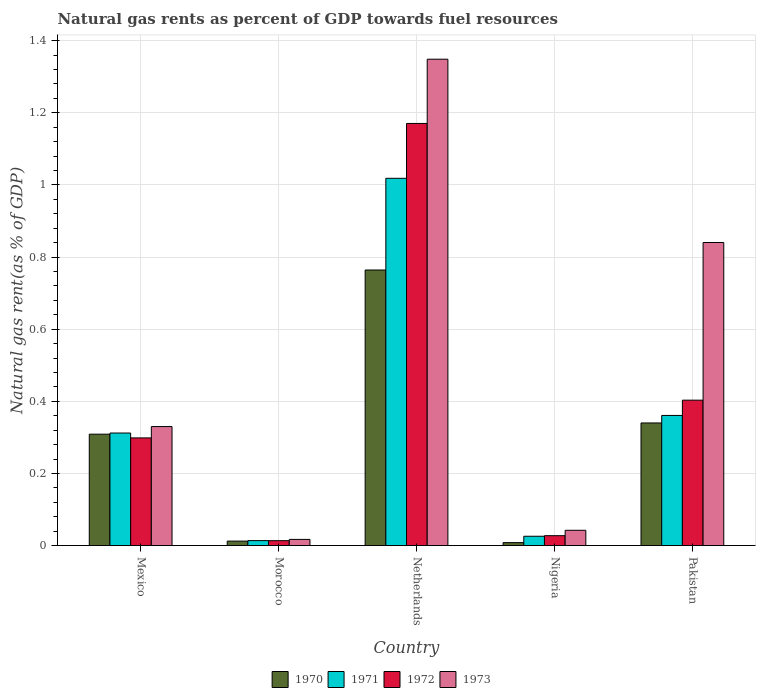How many different coloured bars are there?
Your answer should be compact. 4. How many groups of bars are there?
Give a very brief answer. 5. Are the number of bars on each tick of the X-axis equal?
Provide a succinct answer. Yes. In how many cases, is the number of bars for a given country not equal to the number of legend labels?
Ensure brevity in your answer.  0. What is the natural gas rent in 1973 in Netherlands?
Make the answer very short. 1.35. Across all countries, what is the maximum natural gas rent in 1972?
Provide a succinct answer. 1.17. Across all countries, what is the minimum natural gas rent in 1970?
Your response must be concise. 0.01. In which country was the natural gas rent in 1971 minimum?
Offer a very short reply. Morocco. What is the total natural gas rent in 1972 in the graph?
Keep it short and to the point. 1.91. What is the difference between the natural gas rent in 1970 in Mexico and that in Pakistan?
Offer a very short reply. -0.03. What is the difference between the natural gas rent in 1971 in Morocco and the natural gas rent in 1970 in Nigeria?
Make the answer very short. 0.01. What is the average natural gas rent in 1970 per country?
Make the answer very short. 0.29. What is the difference between the natural gas rent of/in 1970 and natural gas rent of/in 1972 in Netherlands?
Provide a short and direct response. -0.41. In how many countries, is the natural gas rent in 1971 greater than 0.4 %?
Keep it short and to the point. 1. What is the ratio of the natural gas rent in 1972 in Netherlands to that in Pakistan?
Your answer should be compact. 2.9. Is the difference between the natural gas rent in 1970 in Nigeria and Pakistan greater than the difference between the natural gas rent in 1972 in Nigeria and Pakistan?
Offer a very short reply. Yes. What is the difference between the highest and the second highest natural gas rent in 1970?
Ensure brevity in your answer.  0.42. What is the difference between the highest and the lowest natural gas rent in 1971?
Ensure brevity in your answer.  1. In how many countries, is the natural gas rent in 1970 greater than the average natural gas rent in 1970 taken over all countries?
Offer a terse response. 3. What does the 1st bar from the left in Morocco represents?
Make the answer very short. 1970. Is it the case that in every country, the sum of the natural gas rent in 1970 and natural gas rent in 1973 is greater than the natural gas rent in 1972?
Your answer should be compact. Yes. How many bars are there?
Your answer should be very brief. 20. How many countries are there in the graph?
Offer a very short reply. 5. What is the difference between two consecutive major ticks on the Y-axis?
Provide a succinct answer. 0.2. Does the graph contain grids?
Offer a terse response. Yes. Where does the legend appear in the graph?
Your answer should be compact. Bottom center. How many legend labels are there?
Provide a short and direct response. 4. What is the title of the graph?
Ensure brevity in your answer.  Natural gas rents as percent of GDP towards fuel resources. What is the label or title of the X-axis?
Offer a very short reply. Country. What is the label or title of the Y-axis?
Offer a very short reply. Natural gas rent(as % of GDP). What is the Natural gas rent(as % of GDP) of 1970 in Mexico?
Your answer should be very brief. 0.31. What is the Natural gas rent(as % of GDP) of 1971 in Mexico?
Provide a succinct answer. 0.31. What is the Natural gas rent(as % of GDP) in 1972 in Mexico?
Offer a terse response. 0.3. What is the Natural gas rent(as % of GDP) of 1973 in Mexico?
Your answer should be very brief. 0.33. What is the Natural gas rent(as % of GDP) of 1970 in Morocco?
Your response must be concise. 0.01. What is the Natural gas rent(as % of GDP) in 1971 in Morocco?
Make the answer very short. 0.01. What is the Natural gas rent(as % of GDP) of 1972 in Morocco?
Provide a short and direct response. 0.01. What is the Natural gas rent(as % of GDP) of 1973 in Morocco?
Make the answer very short. 0.02. What is the Natural gas rent(as % of GDP) of 1970 in Netherlands?
Offer a very short reply. 0.76. What is the Natural gas rent(as % of GDP) in 1971 in Netherlands?
Your response must be concise. 1.02. What is the Natural gas rent(as % of GDP) in 1972 in Netherlands?
Your response must be concise. 1.17. What is the Natural gas rent(as % of GDP) of 1973 in Netherlands?
Provide a succinct answer. 1.35. What is the Natural gas rent(as % of GDP) of 1970 in Nigeria?
Keep it short and to the point. 0.01. What is the Natural gas rent(as % of GDP) of 1971 in Nigeria?
Offer a very short reply. 0.03. What is the Natural gas rent(as % of GDP) of 1972 in Nigeria?
Keep it short and to the point. 0.03. What is the Natural gas rent(as % of GDP) of 1973 in Nigeria?
Offer a terse response. 0.04. What is the Natural gas rent(as % of GDP) in 1970 in Pakistan?
Keep it short and to the point. 0.34. What is the Natural gas rent(as % of GDP) of 1971 in Pakistan?
Provide a short and direct response. 0.36. What is the Natural gas rent(as % of GDP) of 1972 in Pakistan?
Ensure brevity in your answer.  0.4. What is the Natural gas rent(as % of GDP) of 1973 in Pakistan?
Offer a very short reply. 0.84. Across all countries, what is the maximum Natural gas rent(as % of GDP) of 1970?
Keep it short and to the point. 0.76. Across all countries, what is the maximum Natural gas rent(as % of GDP) in 1971?
Your answer should be very brief. 1.02. Across all countries, what is the maximum Natural gas rent(as % of GDP) in 1972?
Your answer should be very brief. 1.17. Across all countries, what is the maximum Natural gas rent(as % of GDP) in 1973?
Ensure brevity in your answer.  1.35. Across all countries, what is the minimum Natural gas rent(as % of GDP) of 1970?
Offer a terse response. 0.01. Across all countries, what is the minimum Natural gas rent(as % of GDP) of 1971?
Your response must be concise. 0.01. Across all countries, what is the minimum Natural gas rent(as % of GDP) in 1972?
Your answer should be compact. 0.01. Across all countries, what is the minimum Natural gas rent(as % of GDP) in 1973?
Offer a very short reply. 0.02. What is the total Natural gas rent(as % of GDP) in 1970 in the graph?
Your response must be concise. 1.43. What is the total Natural gas rent(as % of GDP) of 1971 in the graph?
Your response must be concise. 1.73. What is the total Natural gas rent(as % of GDP) of 1972 in the graph?
Your response must be concise. 1.91. What is the total Natural gas rent(as % of GDP) of 1973 in the graph?
Provide a short and direct response. 2.58. What is the difference between the Natural gas rent(as % of GDP) of 1970 in Mexico and that in Morocco?
Your answer should be very brief. 0.3. What is the difference between the Natural gas rent(as % of GDP) of 1971 in Mexico and that in Morocco?
Offer a terse response. 0.3. What is the difference between the Natural gas rent(as % of GDP) in 1972 in Mexico and that in Morocco?
Offer a terse response. 0.28. What is the difference between the Natural gas rent(as % of GDP) of 1973 in Mexico and that in Morocco?
Your answer should be very brief. 0.31. What is the difference between the Natural gas rent(as % of GDP) in 1970 in Mexico and that in Netherlands?
Your answer should be compact. -0.46. What is the difference between the Natural gas rent(as % of GDP) of 1971 in Mexico and that in Netherlands?
Keep it short and to the point. -0.71. What is the difference between the Natural gas rent(as % of GDP) in 1972 in Mexico and that in Netherlands?
Make the answer very short. -0.87. What is the difference between the Natural gas rent(as % of GDP) of 1973 in Mexico and that in Netherlands?
Make the answer very short. -1.02. What is the difference between the Natural gas rent(as % of GDP) of 1970 in Mexico and that in Nigeria?
Your answer should be compact. 0.3. What is the difference between the Natural gas rent(as % of GDP) of 1971 in Mexico and that in Nigeria?
Your answer should be very brief. 0.29. What is the difference between the Natural gas rent(as % of GDP) in 1972 in Mexico and that in Nigeria?
Your answer should be very brief. 0.27. What is the difference between the Natural gas rent(as % of GDP) of 1973 in Mexico and that in Nigeria?
Provide a succinct answer. 0.29. What is the difference between the Natural gas rent(as % of GDP) of 1970 in Mexico and that in Pakistan?
Ensure brevity in your answer.  -0.03. What is the difference between the Natural gas rent(as % of GDP) of 1971 in Mexico and that in Pakistan?
Give a very brief answer. -0.05. What is the difference between the Natural gas rent(as % of GDP) of 1972 in Mexico and that in Pakistan?
Your answer should be compact. -0.1. What is the difference between the Natural gas rent(as % of GDP) of 1973 in Mexico and that in Pakistan?
Your response must be concise. -0.51. What is the difference between the Natural gas rent(as % of GDP) of 1970 in Morocco and that in Netherlands?
Keep it short and to the point. -0.75. What is the difference between the Natural gas rent(as % of GDP) of 1971 in Morocco and that in Netherlands?
Make the answer very short. -1. What is the difference between the Natural gas rent(as % of GDP) of 1972 in Morocco and that in Netherlands?
Offer a terse response. -1.16. What is the difference between the Natural gas rent(as % of GDP) of 1973 in Morocco and that in Netherlands?
Offer a very short reply. -1.33. What is the difference between the Natural gas rent(as % of GDP) in 1970 in Morocco and that in Nigeria?
Give a very brief answer. 0. What is the difference between the Natural gas rent(as % of GDP) in 1971 in Morocco and that in Nigeria?
Provide a succinct answer. -0.01. What is the difference between the Natural gas rent(as % of GDP) in 1972 in Morocco and that in Nigeria?
Provide a succinct answer. -0.01. What is the difference between the Natural gas rent(as % of GDP) in 1973 in Morocco and that in Nigeria?
Keep it short and to the point. -0.03. What is the difference between the Natural gas rent(as % of GDP) in 1970 in Morocco and that in Pakistan?
Offer a terse response. -0.33. What is the difference between the Natural gas rent(as % of GDP) in 1971 in Morocco and that in Pakistan?
Keep it short and to the point. -0.35. What is the difference between the Natural gas rent(as % of GDP) in 1972 in Morocco and that in Pakistan?
Provide a short and direct response. -0.39. What is the difference between the Natural gas rent(as % of GDP) in 1973 in Morocco and that in Pakistan?
Give a very brief answer. -0.82. What is the difference between the Natural gas rent(as % of GDP) in 1970 in Netherlands and that in Nigeria?
Your response must be concise. 0.76. What is the difference between the Natural gas rent(as % of GDP) of 1971 in Netherlands and that in Nigeria?
Your answer should be compact. 0.99. What is the difference between the Natural gas rent(as % of GDP) in 1972 in Netherlands and that in Nigeria?
Your answer should be compact. 1.14. What is the difference between the Natural gas rent(as % of GDP) of 1973 in Netherlands and that in Nigeria?
Make the answer very short. 1.31. What is the difference between the Natural gas rent(as % of GDP) of 1970 in Netherlands and that in Pakistan?
Make the answer very short. 0.42. What is the difference between the Natural gas rent(as % of GDP) in 1971 in Netherlands and that in Pakistan?
Your answer should be compact. 0.66. What is the difference between the Natural gas rent(as % of GDP) of 1972 in Netherlands and that in Pakistan?
Provide a short and direct response. 0.77. What is the difference between the Natural gas rent(as % of GDP) of 1973 in Netherlands and that in Pakistan?
Keep it short and to the point. 0.51. What is the difference between the Natural gas rent(as % of GDP) of 1970 in Nigeria and that in Pakistan?
Give a very brief answer. -0.33. What is the difference between the Natural gas rent(as % of GDP) in 1971 in Nigeria and that in Pakistan?
Offer a terse response. -0.34. What is the difference between the Natural gas rent(as % of GDP) in 1972 in Nigeria and that in Pakistan?
Provide a short and direct response. -0.38. What is the difference between the Natural gas rent(as % of GDP) of 1973 in Nigeria and that in Pakistan?
Provide a succinct answer. -0.8. What is the difference between the Natural gas rent(as % of GDP) of 1970 in Mexico and the Natural gas rent(as % of GDP) of 1971 in Morocco?
Make the answer very short. 0.3. What is the difference between the Natural gas rent(as % of GDP) of 1970 in Mexico and the Natural gas rent(as % of GDP) of 1972 in Morocco?
Your answer should be compact. 0.3. What is the difference between the Natural gas rent(as % of GDP) of 1970 in Mexico and the Natural gas rent(as % of GDP) of 1973 in Morocco?
Your response must be concise. 0.29. What is the difference between the Natural gas rent(as % of GDP) in 1971 in Mexico and the Natural gas rent(as % of GDP) in 1972 in Morocco?
Your answer should be compact. 0.3. What is the difference between the Natural gas rent(as % of GDP) in 1971 in Mexico and the Natural gas rent(as % of GDP) in 1973 in Morocco?
Your answer should be compact. 0.29. What is the difference between the Natural gas rent(as % of GDP) in 1972 in Mexico and the Natural gas rent(as % of GDP) in 1973 in Morocco?
Make the answer very short. 0.28. What is the difference between the Natural gas rent(as % of GDP) in 1970 in Mexico and the Natural gas rent(as % of GDP) in 1971 in Netherlands?
Your answer should be compact. -0.71. What is the difference between the Natural gas rent(as % of GDP) of 1970 in Mexico and the Natural gas rent(as % of GDP) of 1972 in Netherlands?
Offer a terse response. -0.86. What is the difference between the Natural gas rent(as % of GDP) of 1970 in Mexico and the Natural gas rent(as % of GDP) of 1973 in Netherlands?
Your response must be concise. -1.04. What is the difference between the Natural gas rent(as % of GDP) of 1971 in Mexico and the Natural gas rent(as % of GDP) of 1972 in Netherlands?
Your answer should be compact. -0.86. What is the difference between the Natural gas rent(as % of GDP) of 1971 in Mexico and the Natural gas rent(as % of GDP) of 1973 in Netherlands?
Make the answer very short. -1.04. What is the difference between the Natural gas rent(as % of GDP) in 1972 in Mexico and the Natural gas rent(as % of GDP) in 1973 in Netherlands?
Keep it short and to the point. -1.05. What is the difference between the Natural gas rent(as % of GDP) in 1970 in Mexico and the Natural gas rent(as % of GDP) in 1971 in Nigeria?
Offer a terse response. 0.28. What is the difference between the Natural gas rent(as % of GDP) in 1970 in Mexico and the Natural gas rent(as % of GDP) in 1972 in Nigeria?
Provide a succinct answer. 0.28. What is the difference between the Natural gas rent(as % of GDP) of 1970 in Mexico and the Natural gas rent(as % of GDP) of 1973 in Nigeria?
Keep it short and to the point. 0.27. What is the difference between the Natural gas rent(as % of GDP) in 1971 in Mexico and the Natural gas rent(as % of GDP) in 1972 in Nigeria?
Your answer should be compact. 0.28. What is the difference between the Natural gas rent(as % of GDP) of 1971 in Mexico and the Natural gas rent(as % of GDP) of 1973 in Nigeria?
Make the answer very short. 0.27. What is the difference between the Natural gas rent(as % of GDP) of 1972 in Mexico and the Natural gas rent(as % of GDP) of 1973 in Nigeria?
Your answer should be compact. 0.26. What is the difference between the Natural gas rent(as % of GDP) in 1970 in Mexico and the Natural gas rent(as % of GDP) in 1971 in Pakistan?
Your answer should be very brief. -0.05. What is the difference between the Natural gas rent(as % of GDP) of 1970 in Mexico and the Natural gas rent(as % of GDP) of 1972 in Pakistan?
Your answer should be very brief. -0.09. What is the difference between the Natural gas rent(as % of GDP) in 1970 in Mexico and the Natural gas rent(as % of GDP) in 1973 in Pakistan?
Ensure brevity in your answer.  -0.53. What is the difference between the Natural gas rent(as % of GDP) of 1971 in Mexico and the Natural gas rent(as % of GDP) of 1972 in Pakistan?
Keep it short and to the point. -0.09. What is the difference between the Natural gas rent(as % of GDP) in 1971 in Mexico and the Natural gas rent(as % of GDP) in 1973 in Pakistan?
Make the answer very short. -0.53. What is the difference between the Natural gas rent(as % of GDP) of 1972 in Mexico and the Natural gas rent(as % of GDP) of 1973 in Pakistan?
Your response must be concise. -0.54. What is the difference between the Natural gas rent(as % of GDP) of 1970 in Morocco and the Natural gas rent(as % of GDP) of 1971 in Netherlands?
Your answer should be compact. -1.01. What is the difference between the Natural gas rent(as % of GDP) of 1970 in Morocco and the Natural gas rent(as % of GDP) of 1972 in Netherlands?
Provide a succinct answer. -1.16. What is the difference between the Natural gas rent(as % of GDP) in 1970 in Morocco and the Natural gas rent(as % of GDP) in 1973 in Netherlands?
Give a very brief answer. -1.34. What is the difference between the Natural gas rent(as % of GDP) of 1971 in Morocco and the Natural gas rent(as % of GDP) of 1972 in Netherlands?
Provide a succinct answer. -1.16. What is the difference between the Natural gas rent(as % of GDP) in 1971 in Morocco and the Natural gas rent(as % of GDP) in 1973 in Netherlands?
Offer a terse response. -1.33. What is the difference between the Natural gas rent(as % of GDP) in 1972 in Morocco and the Natural gas rent(as % of GDP) in 1973 in Netherlands?
Ensure brevity in your answer.  -1.34. What is the difference between the Natural gas rent(as % of GDP) in 1970 in Morocco and the Natural gas rent(as % of GDP) in 1971 in Nigeria?
Make the answer very short. -0.01. What is the difference between the Natural gas rent(as % of GDP) of 1970 in Morocco and the Natural gas rent(as % of GDP) of 1972 in Nigeria?
Your answer should be compact. -0.02. What is the difference between the Natural gas rent(as % of GDP) of 1970 in Morocco and the Natural gas rent(as % of GDP) of 1973 in Nigeria?
Give a very brief answer. -0.03. What is the difference between the Natural gas rent(as % of GDP) in 1971 in Morocco and the Natural gas rent(as % of GDP) in 1972 in Nigeria?
Give a very brief answer. -0.01. What is the difference between the Natural gas rent(as % of GDP) in 1971 in Morocco and the Natural gas rent(as % of GDP) in 1973 in Nigeria?
Your answer should be very brief. -0.03. What is the difference between the Natural gas rent(as % of GDP) in 1972 in Morocco and the Natural gas rent(as % of GDP) in 1973 in Nigeria?
Your response must be concise. -0.03. What is the difference between the Natural gas rent(as % of GDP) of 1970 in Morocco and the Natural gas rent(as % of GDP) of 1971 in Pakistan?
Provide a short and direct response. -0.35. What is the difference between the Natural gas rent(as % of GDP) of 1970 in Morocco and the Natural gas rent(as % of GDP) of 1972 in Pakistan?
Make the answer very short. -0.39. What is the difference between the Natural gas rent(as % of GDP) in 1970 in Morocco and the Natural gas rent(as % of GDP) in 1973 in Pakistan?
Provide a succinct answer. -0.83. What is the difference between the Natural gas rent(as % of GDP) in 1971 in Morocco and the Natural gas rent(as % of GDP) in 1972 in Pakistan?
Give a very brief answer. -0.39. What is the difference between the Natural gas rent(as % of GDP) of 1971 in Morocco and the Natural gas rent(as % of GDP) of 1973 in Pakistan?
Make the answer very short. -0.83. What is the difference between the Natural gas rent(as % of GDP) in 1972 in Morocco and the Natural gas rent(as % of GDP) in 1973 in Pakistan?
Your response must be concise. -0.83. What is the difference between the Natural gas rent(as % of GDP) of 1970 in Netherlands and the Natural gas rent(as % of GDP) of 1971 in Nigeria?
Ensure brevity in your answer.  0.74. What is the difference between the Natural gas rent(as % of GDP) in 1970 in Netherlands and the Natural gas rent(as % of GDP) in 1972 in Nigeria?
Your response must be concise. 0.74. What is the difference between the Natural gas rent(as % of GDP) of 1970 in Netherlands and the Natural gas rent(as % of GDP) of 1973 in Nigeria?
Your response must be concise. 0.72. What is the difference between the Natural gas rent(as % of GDP) in 1972 in Netherlands and the Natural gas rent(as % of GDP) in 1973 in Nigeria?
Make the answer very short. 1.13. What is the difference between the Natural gas rent(as % of GDP) of 1970 in Netherlands and the Natural gas rent(as % of GDP) of 1971 in Pakistan?
Offer a very short reply. 0.4. What is the difference between the Natural gas rent(as % of GDP) in 1970 in Netherlands and the Natural gas rent(as % of GDP) in 1972 in Pakistan?
Keep it short and to the point. 0.36. What is the difference between the Natural gas rent(as % of GDP) in 1970 in Netherlands and the Natural gas rent(as % of GDP) in 1973 in Pakistan?
Provide a succinct answer. -0.08. What is the difference between the Natural gas rent(as % of GDP) of 1971 in Netherlands and the Natural gas rent(as % of GDP) of 1972 in Pakistan?
Offer a terse response. 0.62. What is the difference between the Natural gas rent(as % of GDP) of 1971 in Netherlands and the Natural gas rent(as % of GDP) of 1973 in Pakistan?
Keep it short and to the point. 0.18. What is the difference between the Natural gas rent(as % of GDP) of 1972 in Netherlands and the Natural gas rent(as % of GDP) of 1973 in Pakistan?
Offer a terse response. 0.33. What is the difference between the Natural gas rent(as % of GDP) in 1970 in Nigeria and the Natural gas rent(as % of GDP) in 1971 in Pakistan?
Your answer should be very brief. -0.35. What is the difference between the Natural gas rent(as % of GDP) in 1970 in Nigeria and the Natural gas rent(as % of GDP) in 1972 in Pakistan?
Offer a terse response. -0.4. What is the difference between the Natural gas rent(as % of GDP) in 1970 in Nigeria and the Natural gas rent(as % of GDP) in 1973 in Pakistan?
Provide a short and direct response. -0.83. What is the difference between the Natural gas rent(as % of GDP) of 1971 in Nigeria and the Natural gas rent(as % of GDP) of 1972 in Pakistan?
Your answer should be very brief. -0.38. What is the difference between the Natural gas rent(as % of GDP) of 1971 in Nigeria and the Natural gas rent(as % of GDP) of 1973 in Pakistan?
Keep it short and to the point. -0.81. What is the difference between the Natural gas rent(as % of GDP) in 1972 in Nigeria and the Natural gas rent(as % of GDP) in 1973 in Pakistan?
Your answer should be compact. -0.81. What is the average Natural gas rent(as % of GDP) of 1970 per country?
Offer a terse response. 0.29. What is the average Natural gas rent(as % of GDP) of 1971 per country?
Give a very brief answer. 0.35. What is the average Natural gas rent(as % of GDP) of 1972 per country?
Give a very brief answer. 0.38. What is the average Natural gas rent(as % of GDP) of 1973 per country?
Provide a short and direct response. 0.52. What is the difference between the Natural gas rent(as % of GDP) in 1970 and Natural gas rent(as % of GDP) in 1971 in Mexico?
Your answer should be very brief. -0. What is the difference between the Natural gas rent(as % of GDP) of 1970 and Natural gas rent(as % of GDP) of 1972 in Mexico?
Offer a terse response. 0.01. What is the difference between the Natural gas rent(as % of GDP) of 1970 and Natural gas rent(as % of GDP) of 1973 in Mexico?
Keep it short and to the point. -0.02. What is the difference between the Natural gas rent(as % of GDP) in 1971 and Natural gas rent(as % of GDP) in 1972 in Mexico?
Offer a terse response. 0.01. What is the difference between the Natural gas rent(as % of GDP) in 1971 and Natural gas rent(as % of GDP) in 1973 in Mexico?
Offer a very short reply. -0.02. What is the difference between the Natural gas rent(as % of GDP) in 1972 and Natural gas rent(as % of GDP) in 1973 in Mexico?
Provide a succinct answer. -0.03. What is the difference between the Natural gas rent(as % of GDP) in 1970 and Natural gas rent(as % of GDP) in 1971 in Morocco?
Give a very brief answer. -0. What is the difference between the Natural gas rent(as % of GDP) of 1970 and Natural gas rent(as % of GDP) of 1972 in Morocco?
Provide a short and direct response. -0. What is the difference between the Natural gas rent(as % of GDP) of 1970 and Natural gas rent(as % of GDP) of 1973 in Morocco?
Give a very brief answer. -0. What is the difference between the Natural gas rent(as % of GDP) of 1971 and Natural gas rent(as % of GDP) of 1972 in Morocco?
Offer a terse response. 0. What is the difference between the Natural gas rent(as % of GDP) in 1971 and Natural gas rent(as % of GDP) in 1973 in Morocco?
Offer a terse response. -0. What is the difference between the Natural gas rent(as % of GDP) of 1972 and Natural gas rent(as % of GDP) of 1973 in Morocco?
Provide a short and direct response. -0. What is the difference between the Natural gas rent(as % of GDP) of 1970 and Natural gas rent(as % of GDP) of 1971 in Netherlands?
Make the answer very short. -0.25. What is the difference between the Natural gas rent(as % of GDP) of 1970 and Natural gas rent(as % of GDP) of 1972 in Netherlands?
Provide a succinct answer. -0.41. What is the difference between the Natural gas rent(as % of GDP) in 1970 and Natural gas rent(as % of GDP) in 1973 in Netherlands?
Make the answer very short. -0.58. What is the difference between the Natural gas rent(as % of GDP) of 1971 and Natural gas rent(as % of GDP) of 1972 in Netherlands?
Make the answer very short. -0.15. What is the difference between the Natural gas rent(as % of GDP) of 1971 and Natural gas rent(as % of GDP) of 1973 in Netherlands?
Ensure brevity in your answer.  -0.33. What is the difference between the Natural gas rent(as % of GDP) in 1972 and Natural gas rent(as % of GDP) in 1973 in Netherlands?
Your answer should be very brief. -0.18. What is the difference between the Natural gas rent(as % of GDP) in 1970 and Natural gas rent(as % of GDP) in 1971 in Nigeria?
Provide a succinct answer. -0.02. What is the difference between the Natural gas rent(as % of GDP) in 1970 and Natural gas rent(as % of GDP) in 1972 in Nigeria?
Ensure brevity in your answer.  -0.02. What is the difference between the Natural gas rent(as % of GDP) in 1970 and Natural gas rent(as % of GDP) in 1973 in Nigeria?
Make the answer very short. -0.03. What is the difference between the Natural gas rent(as % of GDP) of 1971 and Natural gas rent(as % of GDP) of 1972 in Nigeria?
Offer a terse response. -0. What is the difference between the Natural gas rent(as % of GDP) in 1971 and Natural gas rent(as % of GDP) in 1973 in Nigeria?
Your response must be concise. -0.02. What is the difference between the Natural gas rent(as % of GDP) of 1972 and Natural gas rent(as % of GDP) of 1973 in Nigeria?
Make the answer very short. -0.01. What is the difference between the Natural gas rent(as % of GDP) of 1970 and Natural gas rent(as % of GDP) of 1971 in Pakistan?
Keep it short and to the point. -0.02. What is the difference between the Natural gas rent(as % of GDP) of 1970 and Natural gas rent(as % of GDP) of 1972 in Pakistan?
Your answer should be compact. -0.06. What is the difference between the Natural gas rent(as % of GDP) in 1970 and Natural gas rent(as % of GDP) in 1973 in Pakistan?
Provide a succinct answer. -0.5. What is the difference between the Natural gas rent(as % of GDP) of 1971 and Natural gas rent(as % of GDP) of 1972 in Pakistan?
Provide a short and direct response. -0.04. What is the difference between the Natural gas rent(as % of GDP) in 1971 and Natural gas rent(as % of GDP) in 1973 in Pakistan?
Make the answer very short. -0.48. What is the difference between the Natural gas rent(as % of GDP) of 1972 and Natural gas rent(as % of GDP) of 1973 in Pakistan?
Your answer should be compact. -0.44. What is the ratio of the Natural gas rent(as % of GDP) of 1970 in Mexico to that in Morocco?
Keep it short and to the point. 25. What is the ratio of the Natural gas rent(as % of GDP) of 1971 in Mexico to that in Morocco?
Your response must be concise. 22.74. What is the ratio of the Natural gas rent(as % of GDP) in 1972 in Mexico to that in Morocco?
Your answer should be very brief. 22.04. What is the ratio of the Natural gas rent(as % of GDP) of 1973 in Mexico to that in Morocco?
Give a very brief answer. 19.3. What is the ratio of the Natural gas rent(as % of GDP) of 1970 in Mexico to that in Netherlands?
Ensure brevity in your answer.  0.4. What is the ratio of the Natural gas rent(as % of GDP) of 1971 in Mexico to that in Netherlands?
Provide a short and direct response. 0.31. What is the ratio of the Natural gas rent(as % of GDP) of 1972 in Mexico to that in Netherlands?
Offer a very short reply. 0.26. What is the ratio of the Natural gas rent(as % of GDP) of 1973 in Mexico to that in Netherlands?
Your response must be concise. 0.24. What is the ratio of the Natural gas rent(as % of GDP) in 1970 in Mexico to that in Nigeria?
Provide a short and direct response. 37.97. What is the ratio of the Natural gas rent(as % of GDP) in 1971 in Mexico to that in Nigeria?
Your response must be concise. 12.1. What is the ratio of the Natural gas rent(as % of GDP) of 1972 in Mexico to that in Nigeria?
Make the answer very short. 10.89. What is the ratio of the Natural gas rent(as % of GDP) of 1973 in Mexico to that in Nigeria?
Provide a succinct answer. 7.79. What is the ratio of the Natural gas rent(as % of GDP) in 1970 in Mexico to that in Pakistan?
Your answer should be compact. 0.91. What is the ratio of the Natural gas rent(as % of GDP) of 1971 in Mexico to that in Pakistan?
Keep it short and to the point. 0.86. What is the ratio of the Natural gas rent(as % of GDP) in 1972 in Mexico to that in Pakistan?
Offer a very short reply. 0.74. What is the ratio of the Natural gas rent(as % of GDP) of 1973 in Mexico to that in Pakistan?
Your response must be concise. 0.39. What is the ratio of the Natural gas rent(as % of GDP) in 1970 in Morocco to that in Netherlands?
Give a very brief answer. 0.02. What is the ratio of the Natural gas rent(as % of GDP) of 1971 in Morocco to that in Netherlands?
Your answer should be compact. 0.01. What is the ratio of the Natural gas rent(as % of GDP) in 1972 in Morocco to that in Netherlands?
Provide a succinct answer. 0.01. What is the ratio of the Natural gas rent(as % of GDP) in 1973 in Morocco to that in Netherlands?
Your answer should be compact. 0.01. What is the ratio of the Natural gas rent(as % of GDP) of 1970 in Morocco to that in Nigeria?
Your response must be concise. 1.52. What is the ratio of the Natural gas rent(as % of GDP) in 1971 in Morocco to that in Nigeria?
Offer a very short reply. 0.53. What is the ratio of the Natural gas rent(as % of GDP) of 1972 in Morocco to that in Nigeria?
Provide a short and direct response. 0.49. What is the ratio of the Natural gas rent(as % of GDP) of 1973 in Morocco to that in Nigeria?
Offer a terse response. 0.4. What is the ratio of the Natural gas rent(as % of GDP) of 1970 in Morocco to that in Pakistan?
Give a very brief answer. 0.04. What is the ratio of the Natural gas rent(as % of GDP) in 1971 in Morocco to that in Pakistan?
Provide a short and direct response. 0.04. What is the ratio of the Natural gas rent(as % of GDP) in 1972 in Morocco to that in Pakistan?
Make the answer very short. 0.03. What is the ratio of the Natural gas rent(as % of GDP) in 1973 in Morocco to that in Pakistan?
Your response must be concise. 0.02. What is the ratio of the Natural gas rent(as % of GDP) in 1970 in Netherlands to that in Nigeria?
Offer a very short reply. 93.94. What is the ratio of the Natural gas rent(as % of GDP) in 1971 in Netherlands to that in Nigeria?
Ensure brevity in your answer.  39.48. What is the ratio of the Natural gas rent(as % of GDP) in 1972 in Netherlands to that in Nigeria?
Ensure brevity in your answer.  42.7. What is the ratio of the Natural gas rent(as % of GDP) in 1973 in Netherlands to that in Nigeria?
Provide a short and direct response. 31.84. What is the ratio of the Natural gas rent(as % of GDP) of 1970 in Netherlands to that in Pakistan?
Your answer should be compact. 2.25. What is the ratio of the Natural gas rent(as % of GDP) of 1971 in Netherlands to that in Pakistan?
Provide a short and direct response. 2.82. What is the ratio of the Natural gas rent(as % of GDP) in 1972 in Netherlands to that in Pakistan?
Make the answer very short. 2.9. What is the ratio of the Natural gas rent(as % of GDP) of 1973 in Netherlands to that in Pakistan?
Give a very brief answer. 1.6. What is the ratio of the Natural gas rent(as % of GDP) in 1970 in Nigeria to that in Pakistan?
Keep it short and to the point. 0.02. What is the ratio of the Natural gas rent(as % of GDP) in 1971 in Nigeria to that in Pakistan?
Offer a very short reply. 0.07. What is the ratio of the Natural gas rent(as % of GDP) of 1972 in Nigeria to that in Pakistan?
Provide a succinct answer. 0.07. What is the ratio of the Natural gas rent(as % of GDP) in 1973 in Nigeria to that in Pakistan?
Make the answer very short. 0.05. What is the difference between the highest and the second highest Natural gas rent(as % of GDP) in 1970?
Make the answer very short. 0.42. What is the difference between the highest and the second highest Natural gas rent(as % of GDP) in 1971?
Provide a succinct answer. 0.66. What is the difference between the highest and the second highest Natural gas rent(as % of GDP) in 1972?
Your response must be concise. 0.77. What is the difference between the highest and the second highest Natural gas rent(as % of GDP) in 1973?
Give a very brief answer. 0.51. What is the difference between the highest and the lowest Natural gas rent(as % of GDP) of 1970?
Provide a succinct answer. 0.76. What is the difference between the highest and the lowest Natural gas rent(as % of GDP) in 1972?
Offer a terse response. 1.16. What is the difference between the highest and the lowest Natural gas rent(as % of GDP) in 1973?
Your answer should be very brief. 1.33. 